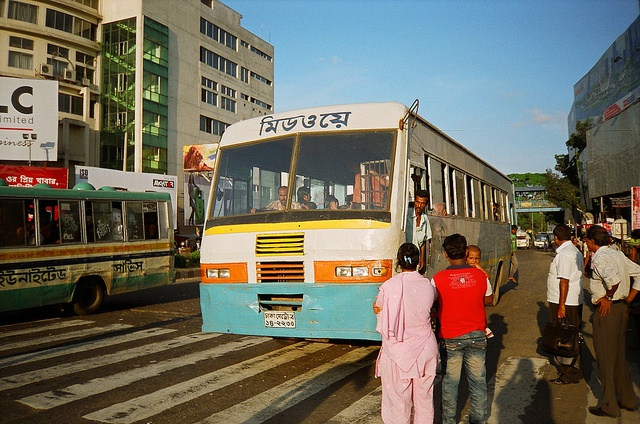Describe the objects in this image and their specific colors. I can see bus in black, lightgray, gray, turquoise, and olive tones, bus in black, olive, maroon, and gray tones, people in black, lightpink, and pink tones, people in black, red, gray, and darkgreen tones, and people in black, tan, and maroon tones in this image. 